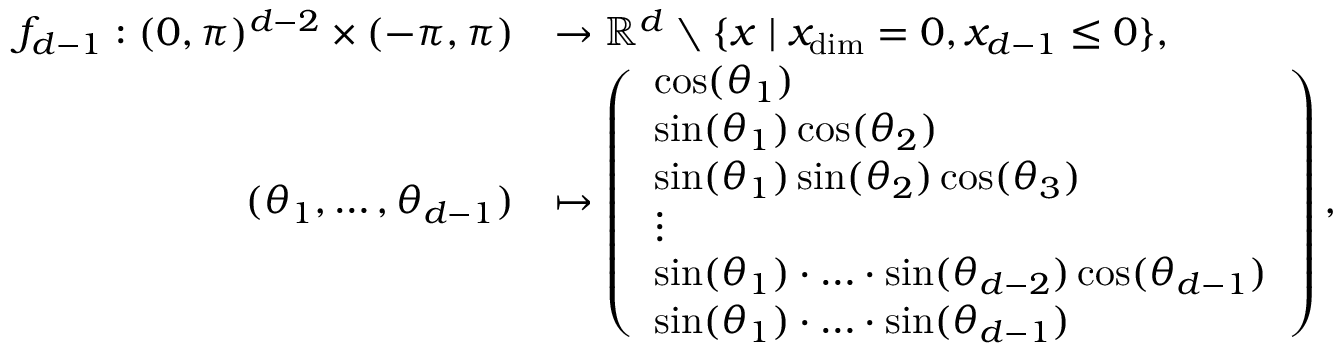Convert formula to latex. <formula><loc_0><loc_0><loc_500><loc_500>\begin{array} { r l } { f _ { d - 1 } \colon ( 0 , \pi ) ^ { d - 2 } \times ( - \pi , \pi ) } & { \to \mathbb { R } ^ { d } \ \{ x | x _ { \dim } = 0 , x _ { d - 1 } \leq 0 \} , } \\ { ( \theta _ { 1 } , \dots , \theta _ { d - 1 } ) } & { \mapsto \left ( \begin{array} { l } { \cos ( \theta _ { 1 } ) } \\ { \sin ( \theta _ { 1 } ) \cos ( \theta _ { 2 } ) } \\ { \sin ( \theta _ { 1 } ) \sin ( \theta _ { 2 } ) \cos ( \theta _ { 3 } ) } \\ { \vdots } \\ { \sin ( \theta _ { 1 } ) \cdot \dots \cdot \sin ( \theta _ { d - 2 } ) \cos ( \theta _ { d - 1 } ) } \\ { \sin ( \theta _ { 1 } ) \cdot \dots \cdot \sin ( \theta _ { d - 1 } ) } \end{array} \right ) , } \end{array}</formula> 